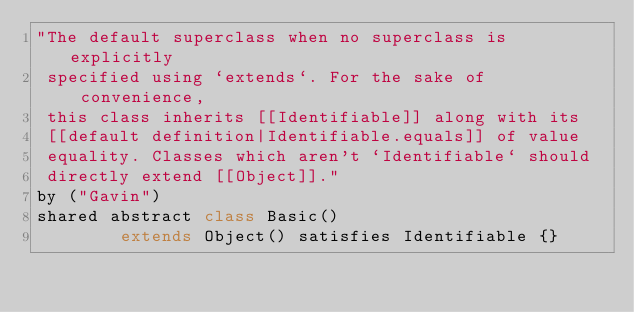Convert code to text. <code><loc_0><loc_0><loc_500><loc_500><_Ceylon_>"The default superclass when no superclass is explicitly
 specified using `extends`. For the sake of convenience, 
 this class inherits [[Identifiable]] along with its
 [[default definition|Identifiable.equals]] of value 
 equality. Classes which aren't `Identifiable` should 
 directly extend [[Object]]."
by ("Gavin")
shared abstract class Basic() 
        extends Object() satisfies Identifiable {}</code> 